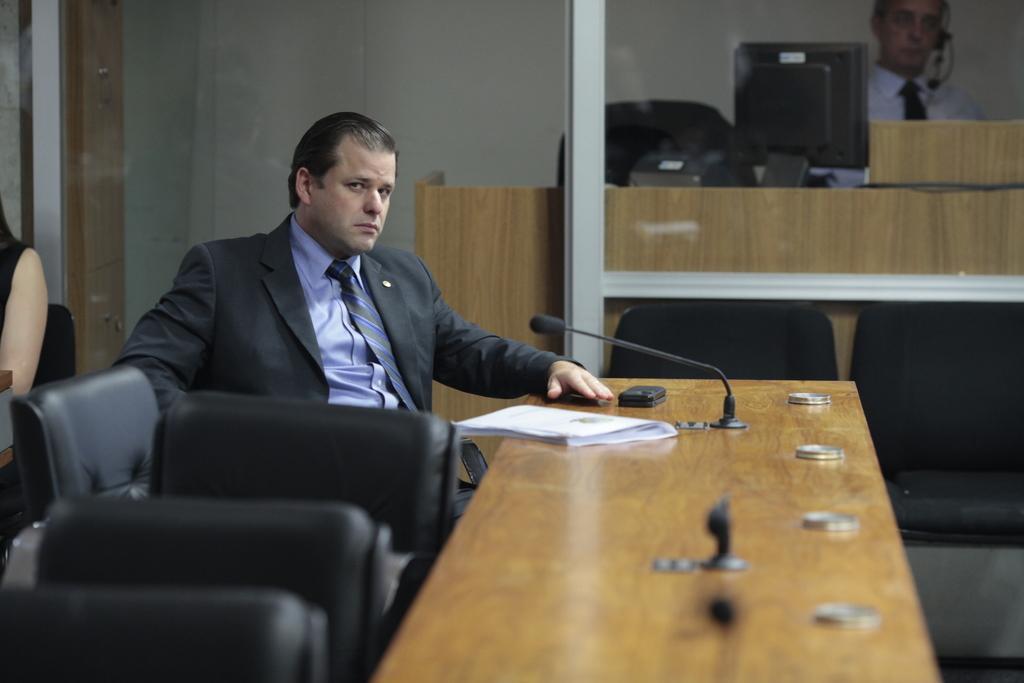In one or two sentences, can you explain what this image depicts? This is the picture where we have a person sitting on the sofa in front of the table on which there is a mic a note and behind him there is a cabin in which there is a person sitting on the chair in front of the table on which there is a system. 